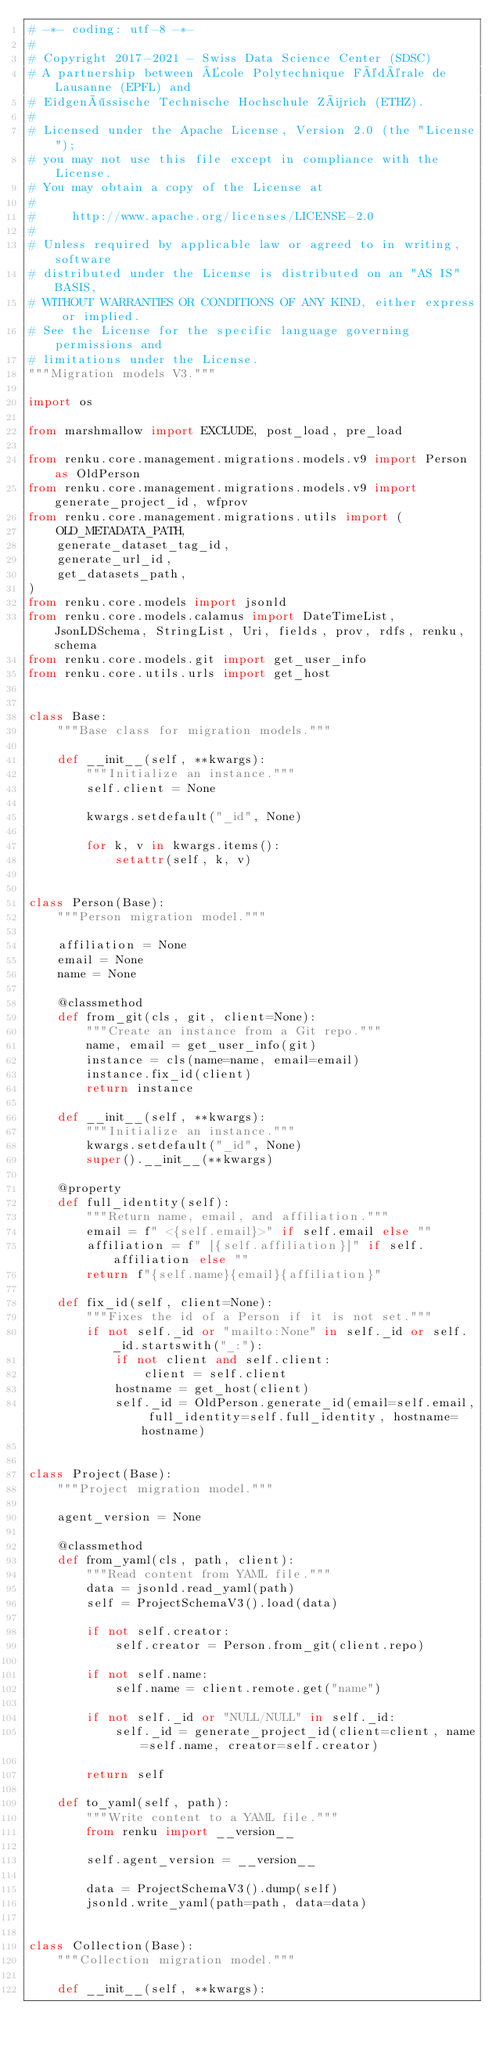Convert code to text. <code><loc_0><loc_0><loc_500><loc_500><_Python_># -*- coding: utf-8 -*-
#
# Copyright 2017-2021 - Swiss Data Science Center (SDSC)
# A partnership between École Polytechnique Fédérale de Lausanne (EPFL) and
# Eidgenössische Technische Hochschule Zürich (ETHZ).
#
# Licensed under the Apache License, Version 2.0 (the "License");
# you may not use this file except in compliance with the License.
# You may obtain a copy of the License at
#
#     http://www.apache.org/licenses/LICENSE-2.0
#
# Unless required by applicable law or agreed to in writing, software
# distributed under the License is distributed on an "AS IS" BASIS,
# WITHOUT WARRANTIES OR CONDITIONS OF ANY KIND, either express or implied.
# See the License for the specific language governing permissions and
# limitations under the License.
"""Migration models V3."""

import os

from marshmallow import EXCLUDE, post_load, pre_load

from renku.core.management.migrations.models.v9 import Person as OldPerson
from renku.core.management.migrations.models.v9 import generate_project_id, wfprov
from renku.core.management.migrations.utils import (
    OLD_METADATA_PATH,
    generate_dataset_tag_id,
    generate_url_id,
    get_datasets_path,
)
from renku.core.models import jsonld
from renku.core.models.calamus import DateTimeList, JsonLDSchema, StringList, Uri, fields, prov, rdfs, renku, schema
from renku.core.models.git import get_user_info
from renku.core.utils.urls import get_host


class Base:
    """Base class for migration models."""

    def __init__(self, **kwargs):
        """Initialize an instance."""
        self.client = None

        kwargs.setdefault("_id", None)

        for k, v in kwargs.items():
            setattr(self, k, v)


class Person(Base):
    """Person migration model."""

    affiliation = None
    email = None
    name = None

    @classmethod
    def from_git(cls, git, client=None):
        """Create an instance from a Git repo."""
        name, email = get_user_info(git)
        instance = cls(name=name, email=email)
        instance.fix_id(client)
        return instance

    def __init__(self, **kwargs):
        """Initialize an instance."""
        kwargs.setdefault("_id", None)
        super().__init__(**kwargs)

    @property
    def full_identity(self):
        """Return name, email, and affiliation."""
        email = f" <{self.email}>" if self.email else ""
        affiliation = f" [{self.affiliation}]" if self.affiliation else ""
        return f"{self.name}{email}{affiliation}"

    def fix_id(self, client=None):
        """Fixes the id of a Person if it is not set."""
        if not self._id or "mailto:None" in self._id or self._id.startswith("_:"):
            if not client and self.client:
                client = self.client
            hostname = get_host(client)
            self._id = OldPerson.generate_id(email=self.email, full_identity=self.full_identity, hostname=hostname)


class Project(Base):
    """Project migration model."""

    agent_version = None

    @classmethod
    def from_yaml(cls, path, client):
        """Read content from YAML file."""
        data = jsonld.read_yaml(path)
        self = ProjectSchemaV3().load(data)

        if not self.creator:
            self.creator = Person.from_git(client.repo)

        if not self.name:
            self.name = client.remote.get("name")

        if not self._id or "NULL/NULL" in self._id:
            self._id = generate_project_id(client=client, name=self.name, creator=self.creator)

        return self

    def to_yaml(self, path):
        """Write content to a YAML file."""
        from renku import __version__

        self.agent_version = __version__

        data = ProjectSchemaV3().dump(self)
        jsonld.write_yaml(path=path, data=data)


class Collection(Base):
    """Collection migration model."""

    def __init__(self, **kwargs):</code> 